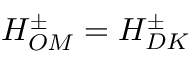<formula> <loc_0><loc_0><loc_500><loc_500>H _ { O M } ^ { \pm } = H _ { D K } ^ { \pm }</formula> 